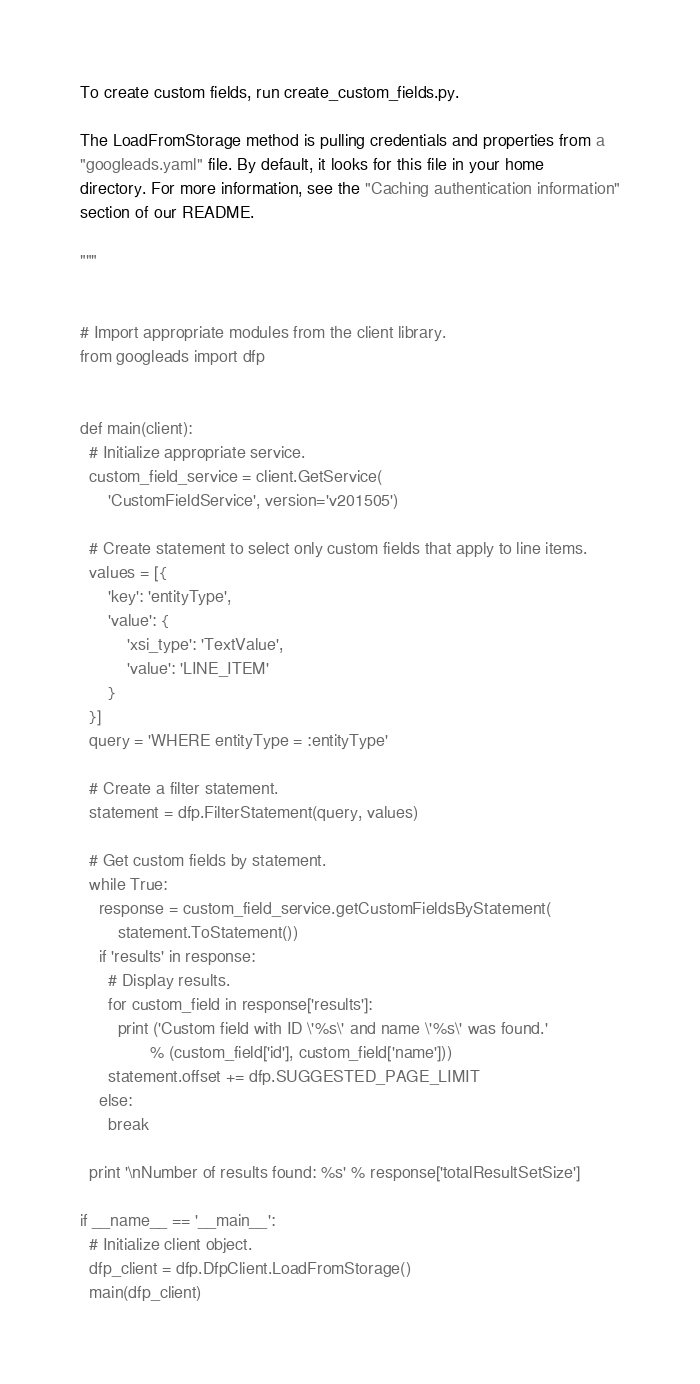Convert code to text. <code><loc_0><loc_0><loc_500><loc_500><_Python_>
To create custom fields, run create_custom_fields.py.

The LoadFromStorage method is pulling credentials and properties from a
"googleads.yaml" file. By default, it looks for this file in your home
directory. For more information, see the "Caching authentication information"
section of our README.

"""


# Import appropriate modules from the client library.
from googleads import dfp


def main(client):
  # Initialize appropriate service.
  custom_field_service = client.GetService(
      'CustomFieldService', version='v201505')

  # Create statement to select only custom fields that apply to line items.
  values = [{
      'key': 'entityType',
      'value': {
          'xsi_type': 'TextValue',
          'value': 'LINE_ITEM'
      }
  }]
  query = 'WHERE entityType = :entityType'

  # Create a filter statement.
  statement = dfp.FilterStatement(query, values)

  # Get custom fields by statement.
  while True:
    response = custom_field_service.getCustomFieldsByStatement(
        statement.ToStatement())
    if 'results' in response:
      # Display results.
      for custom_field in response['results']:
        print ('Custom field with ID \'%s\' and name \'%s\' was found.'
               % (custom_field['id'], custom_field['name']))
      statement.offset += dfp.SUGGESTED_PAGE_LIMIT
    else:
      break

  print '\nNumber of results found: %s' % response['totalResultSetSize']

if __name__ == '__main__':
  # Initialize client object.
  dfp_client = dfp.DfpClient.LoadFromStorage()
  main(dfp_client)
</code> 